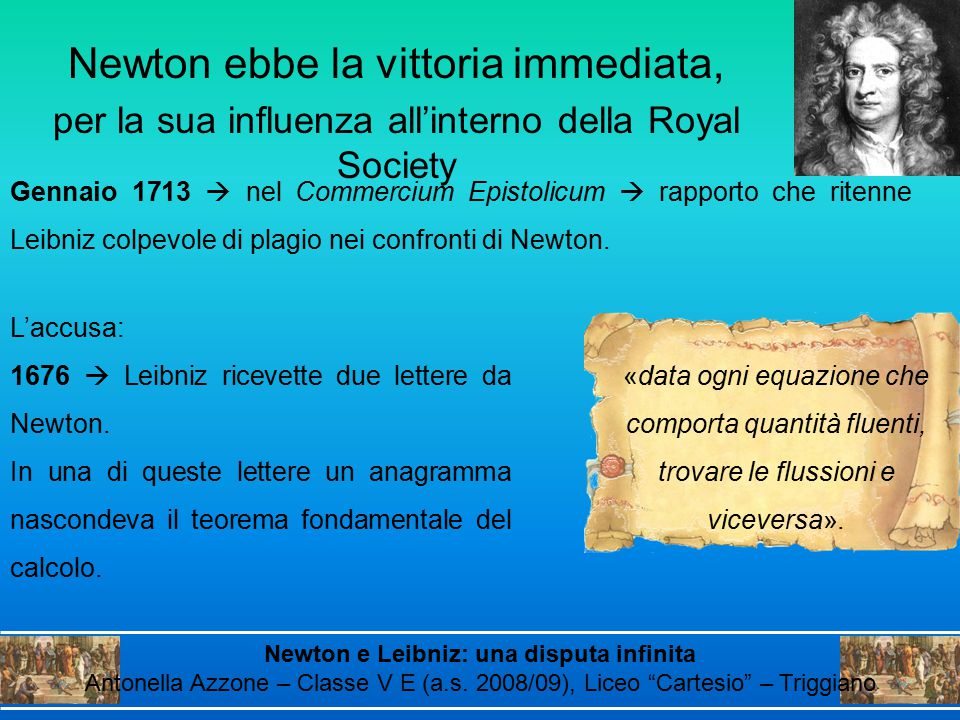Based on the text, recreate a short dialogue between Newton and Leibniz right after the anagram letter was received. Newton: 'I trust you received my latest communication, Herr Leibniz. I have encoded a significant theorem within that anagram.'

Leibniz: 'Indeed, Sir Newton. An intriguing strategy, but why such secrecy?'

Newton: 'In these times, intellectual theft is not uncommon. This ensures my priority without relinquishing the prize entirely.'

Leibniz: 'Ah, a wise precaution. Rest assured, I am quite capable of discovering truths independently.'

Newton: 'We shall see if your methods can stand the test of time.' 